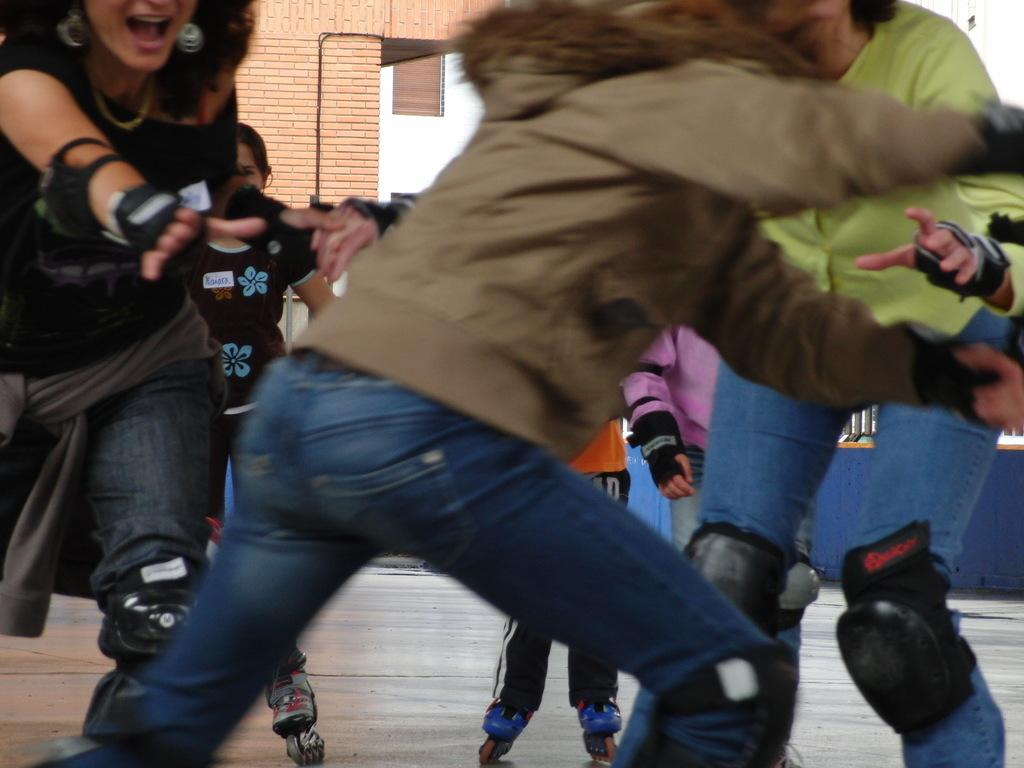What are the people in the image doing? The people are skating in the image. What can be seen in the background of the image? There is a building in the background of the image. What is the surface on which the people are skating? There is a floor visible at the bottom of the image. What type of cracker is being used as a prop in the image? There is no cracker present in the image. How many beams are supporting the building in the background? The image does not provide enough detail to determine the number of beams supporting the building in the background. 